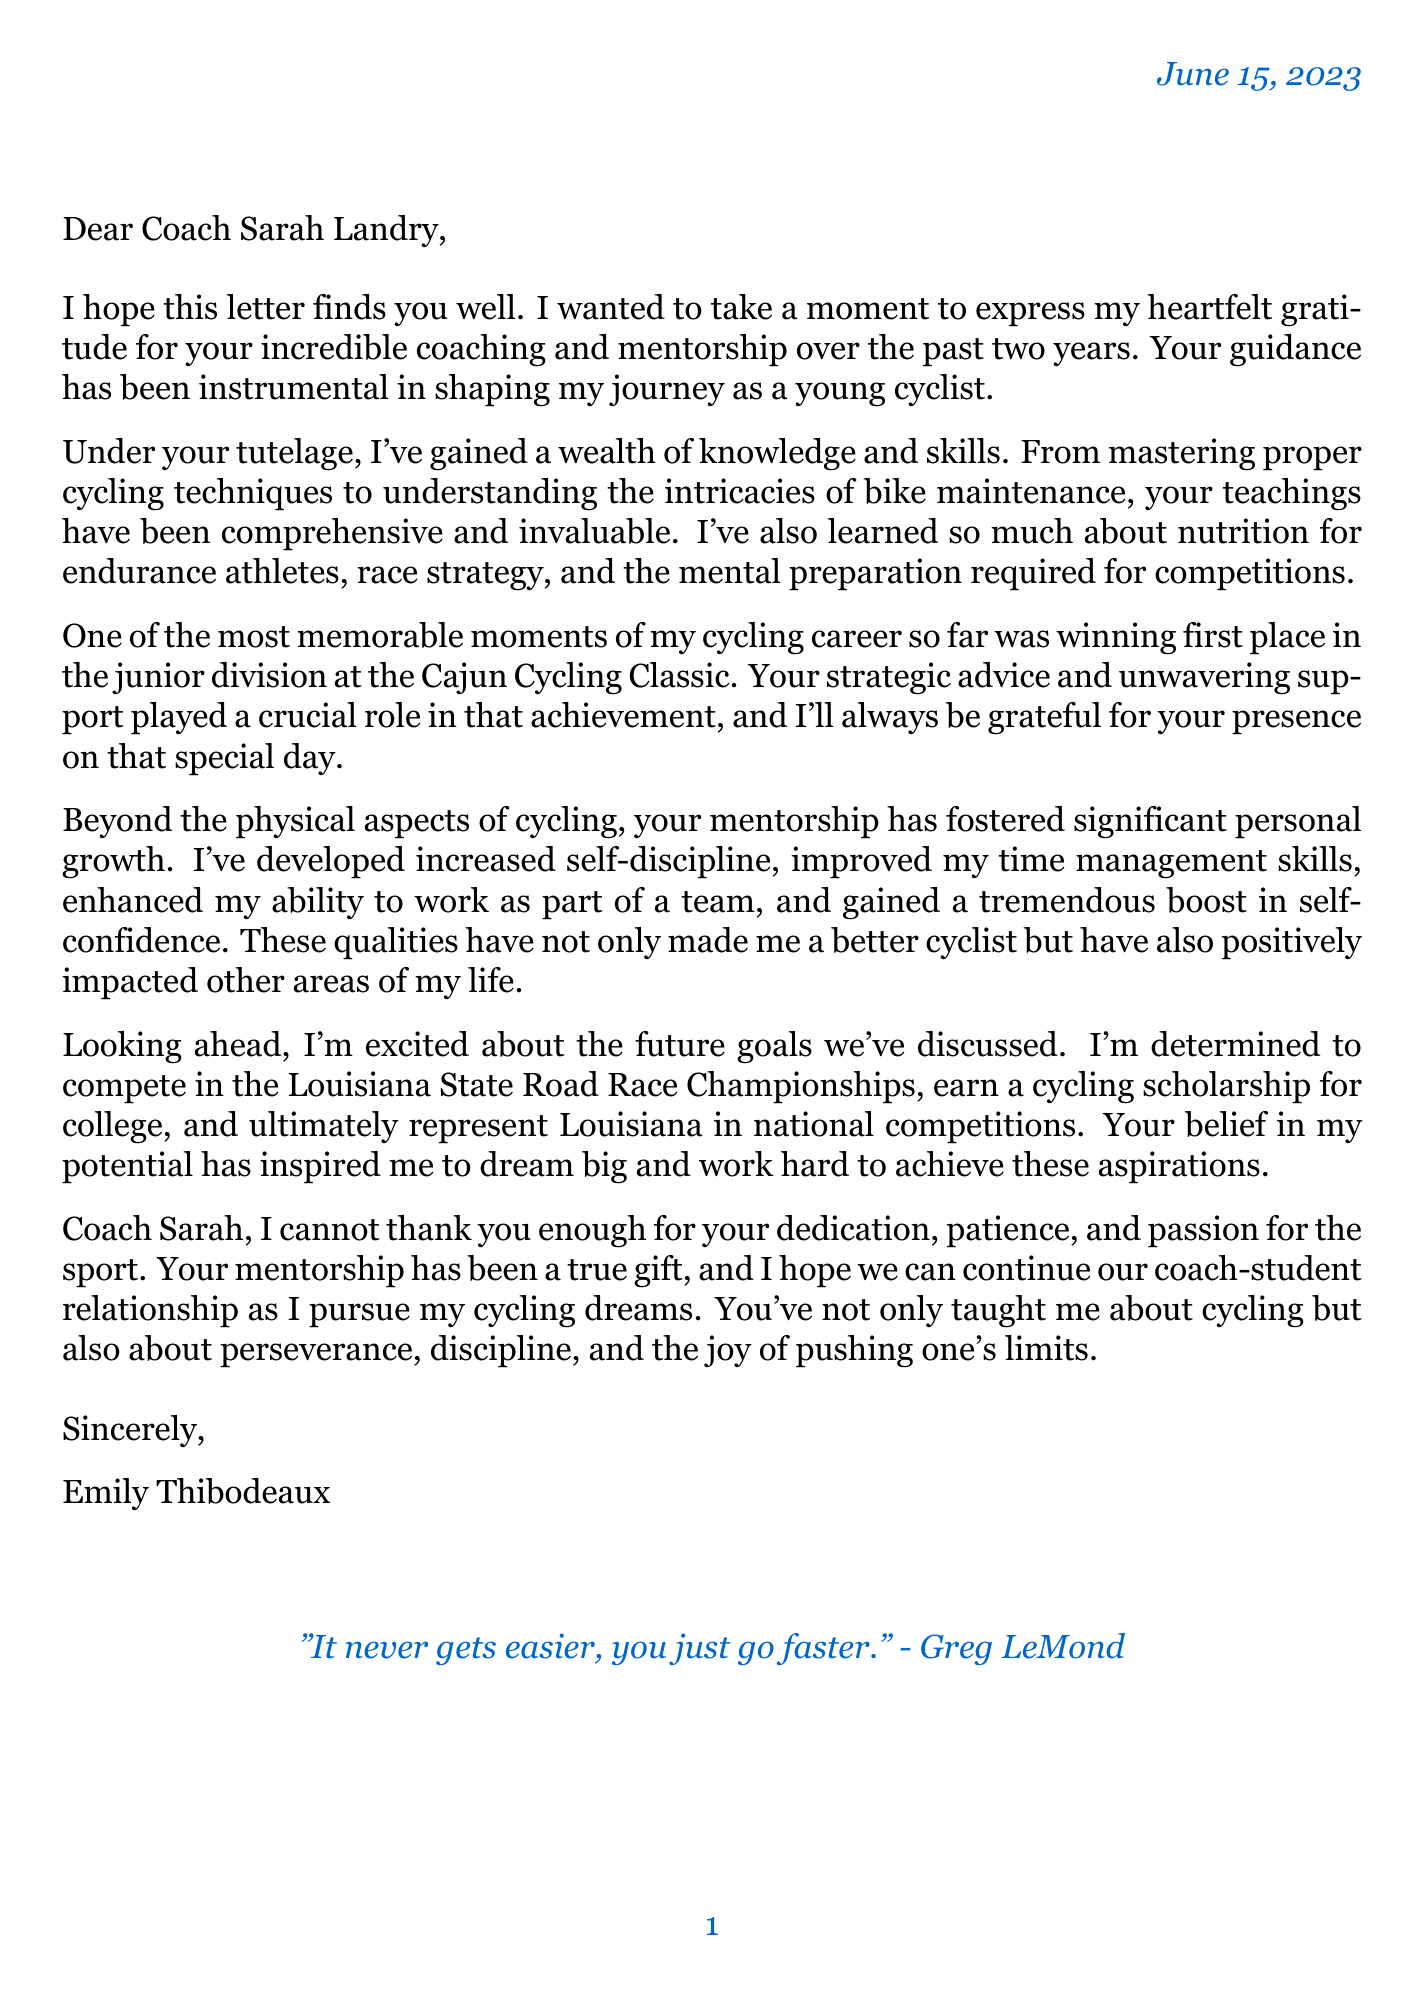What is the name of the coach? The letter addresses Coach Sarah, indicating her name.
Answer: Sarah Landry How long has the coaching relationship lasted? The opening paragraph mentions the duration of coaching.
Answer: 2 years What was the memorable achievement mentioned? The letter specifies a significant moment in the student's cycling career.
Answer: Winning first place in the junior division at the Cajun Cycling Classic Name one skill learned during coaching. The list of skills learned is highlighted in the document.
Answer: Proper cycling techniques What future goal does Emily have? The body of the letter discusses Emily's aspirations.
Answer: Compete in the Louisiana State Road Race Championships Which hometown is Emily from? The student details section provides the hometown information.
Answer: Lafayette, Louisiana What is a key character trait developed through coaching? The document discusses personal growth and skills.
Answer: Self-discipline What is the inspirational quote included in the letter? The closing section features a quote attributed to a well-known cyclist.
Answer: "It never gets easier, you just go faster." - Greg LeMond 